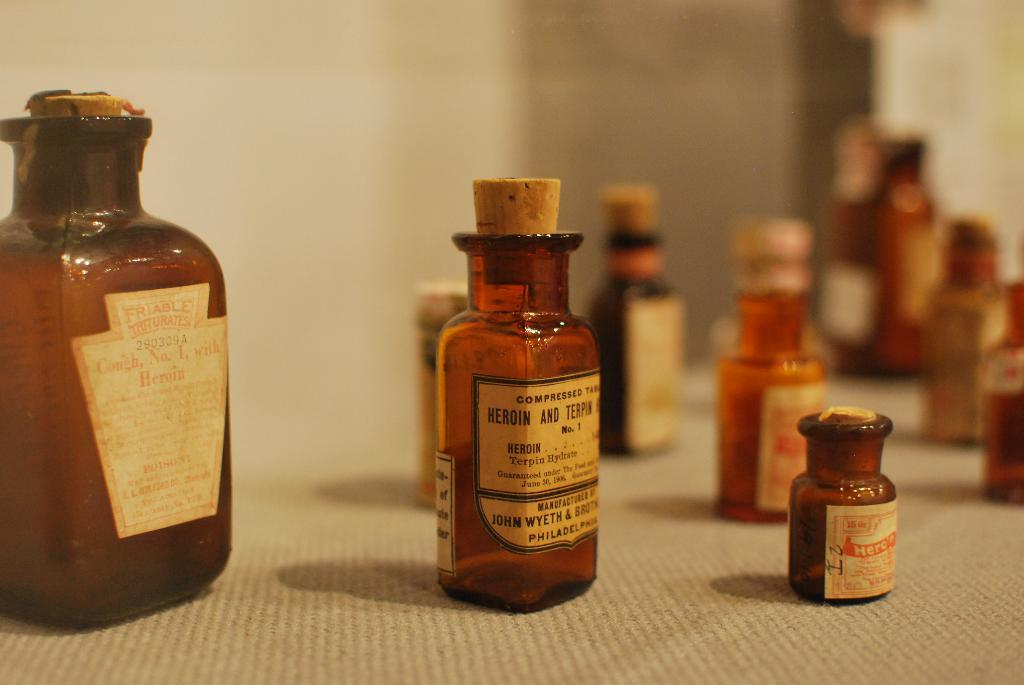<image>
Present a compact description of the photo's key features. A bottle that is marked heroin and terpin no 1 